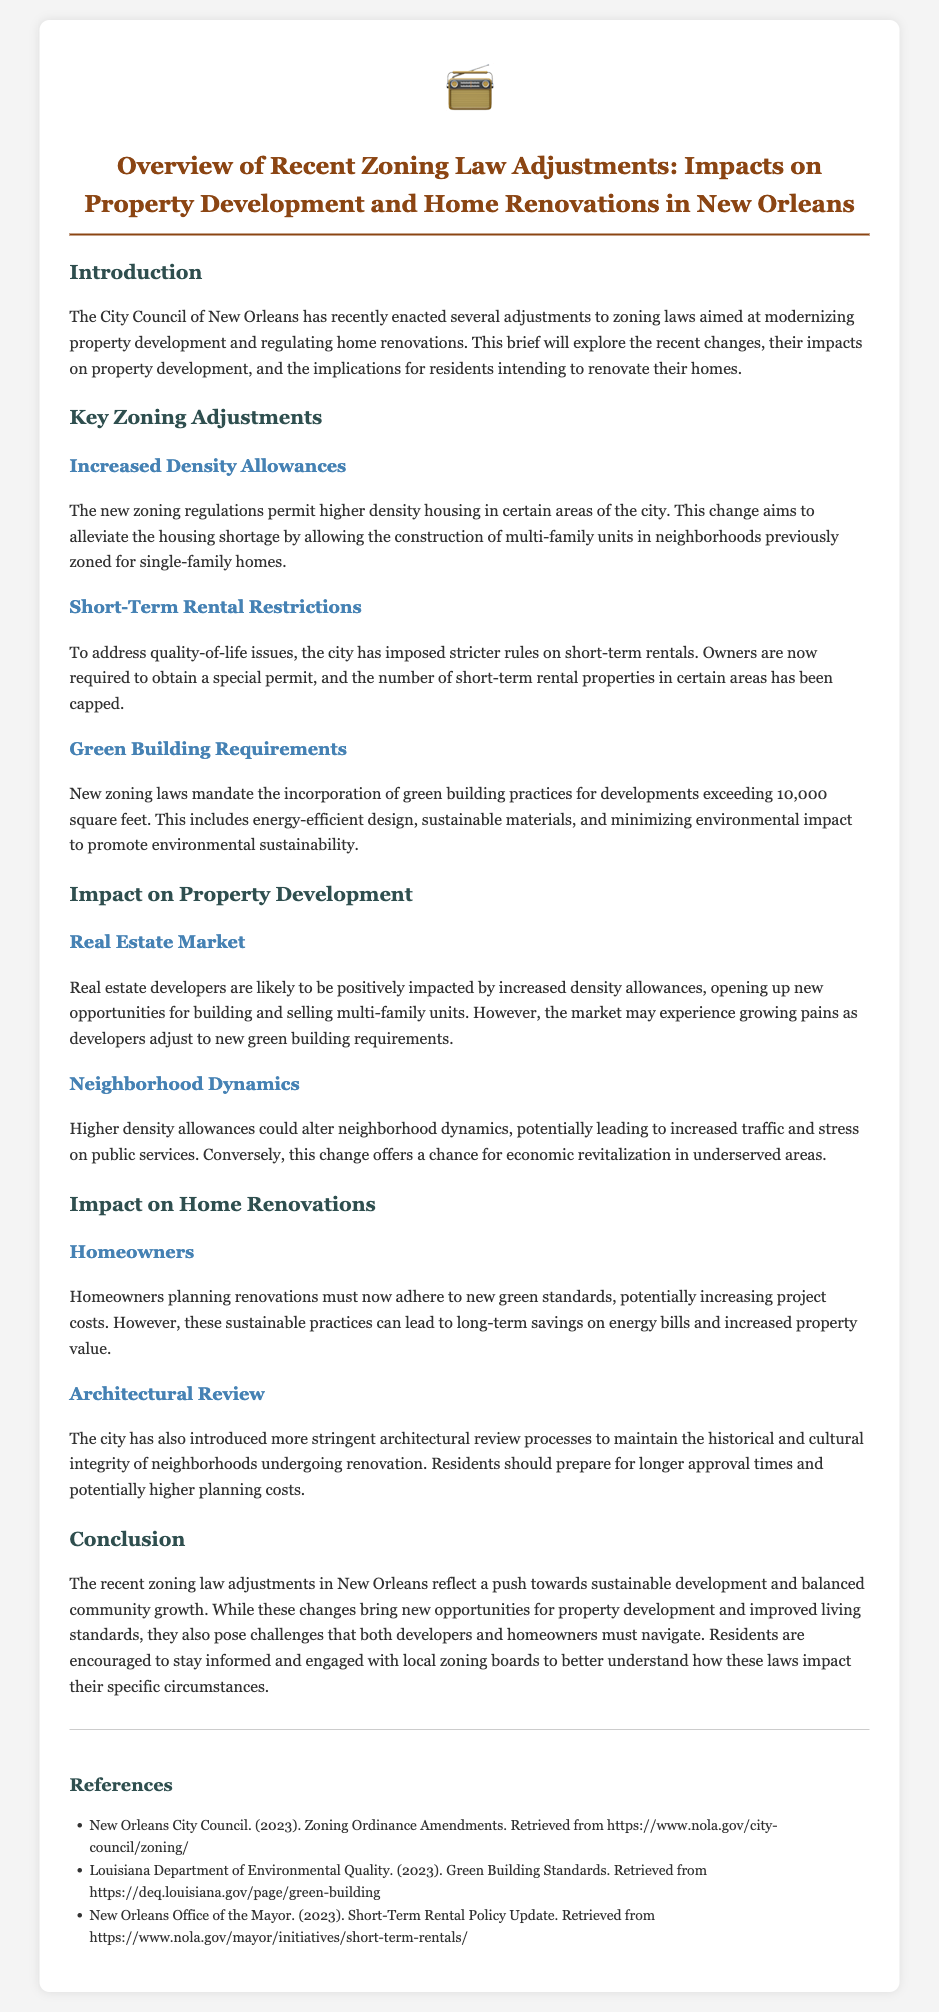What are the new zoning regulations aimed at? The new zoning regulations are aimed at modernizing property development and regulating home renovations.
Answer: Modernizing property development and regulating home renovations What is the new requirement for developments exceeding 10,000 square feet? The new requirement mandates the incorporation of green building practices for developments exceeding 10,000 square feet.
Answer: Incorporation of green building practices What is the cap on short-term rental properties meant to address? The cap on short-term rental properties is meant to address quality-of-life issues.
Answer: Quality-of-life issues How might increased density allowances impact neighborhood dynamics? Higher density allowances could alter neighborhood dynamics, potentially leading to increased traffic and stress on public services.
Answer: Increased traffic and stress on public services What should homeowners expect regarding project costs with the new regulations? Homeowners should expect increased project costs due to adherence to new green standards.
Answer: Increased project costs What is the implication of stricter architectural review processes? Stricter architectural review processes may lead to longer approval times and potentially higher planning costs.
Answer: Longer approval times and higher planning costs What opportunity might developers miss from increased density allowances? Developers may experience growing pains as they adjust to new green building requirements.
Answer: Growing pains due to new requirements What are residents encouraged to do regarding the new zoning laws? Residents are encouraged to stay informed and engaged with local zoning boards.
Answer: Stay informed and engaged with local zoning boards 